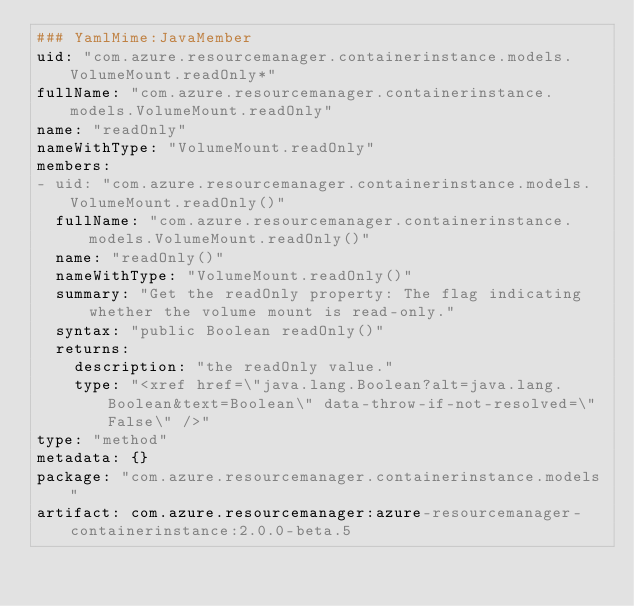<code> <loc_0><loc_0><loc_500><loc_500><_YAML_>### YamlMime:JavaMember
uid: "com.azure.resourcemanager.containerinstance.models.VolumeMount.readOnly*"
fullName: "com.azure.resourcemanager.containerinstance.models.VolumeMount.readOnly"
name: "readOnly"
nameWithType: "VolumeMount.readOnly"
members:
- uid: "com.azure.resourcemanager.containerinstance.models.VolumeMount.readOnly()"
  fullName: "com.azure.resourcemanager.containerinstance.models.VolumeMount.readOnly()"
  name: "readOnly()"
  nameWithType: "VolumeMount.readOnly()"
  summary: "Get the readOnly property: The flag indicating whether the volume mount is read-only."
  syntax: "public Boolean readOnly()"
  returns:
    description: "the readOnly value."
    type: "<xref href=\"java.lang.Boolean?alt=java.lang.Boolean&text=Boolean\" data-throw-if-not-resolved=\"False\" />"
type: "method"
metadata: {}
package: "com.azure.resourcemanager.containerinstance.models"
artifact: com.azure.resourcemanager:azure-resourcemanager-containerinstance:2.0.0-beta.5
</code> 